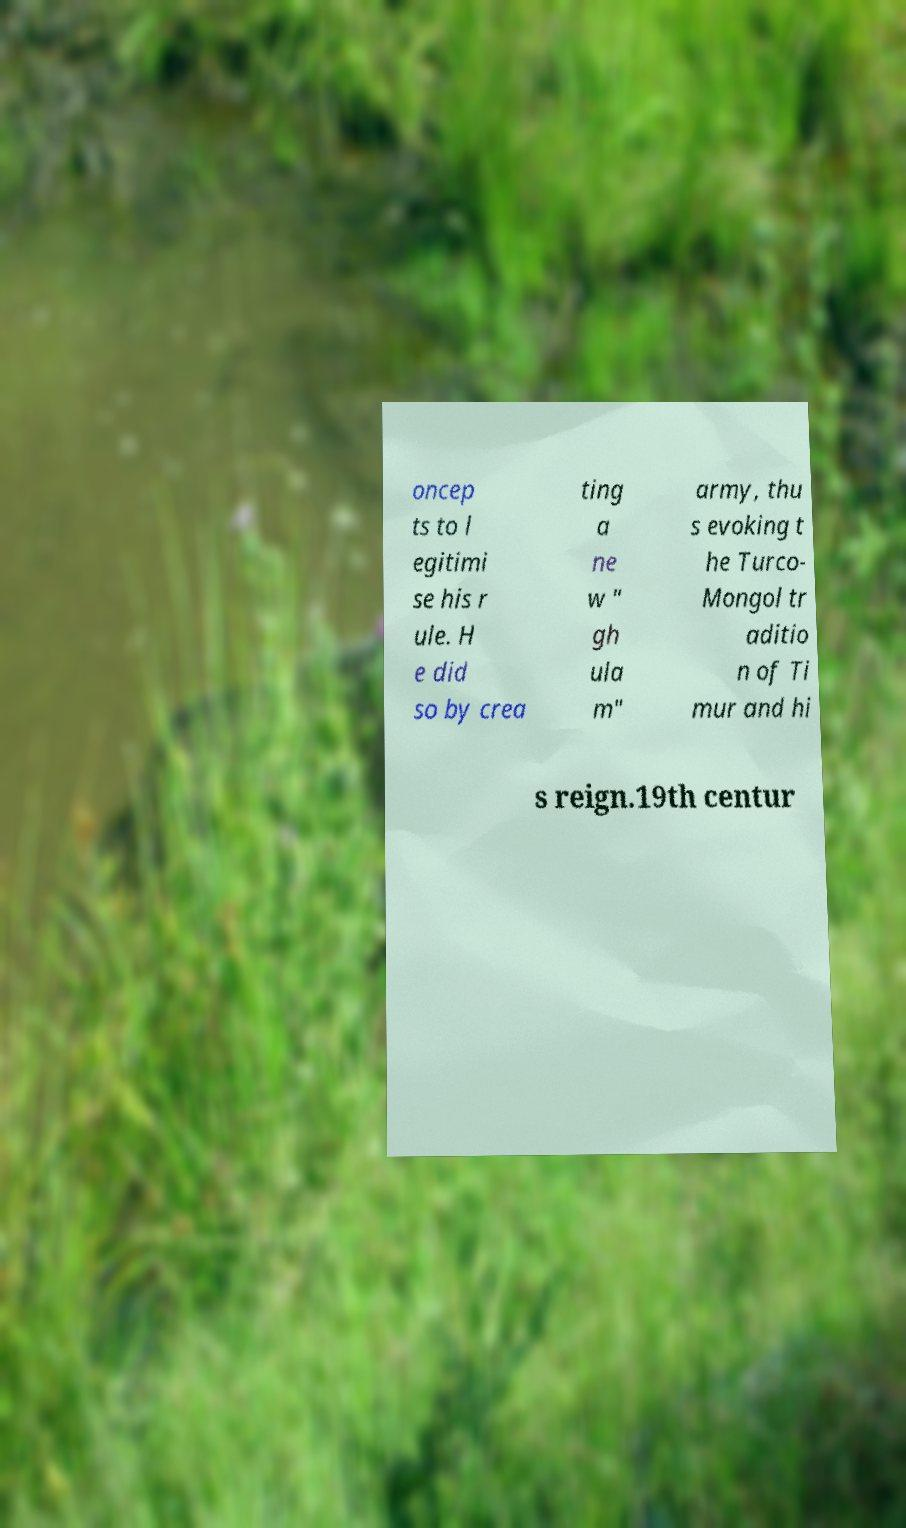Please read and relay the text visible in this image. What does it say? oncep ts to l egitimi se his r ule. H e did so by crea ting a ne w " gh ula m" army, thu s evoking t he Turco- Mongol tr aditio n of Ti mur and hi s reign.19th centur 